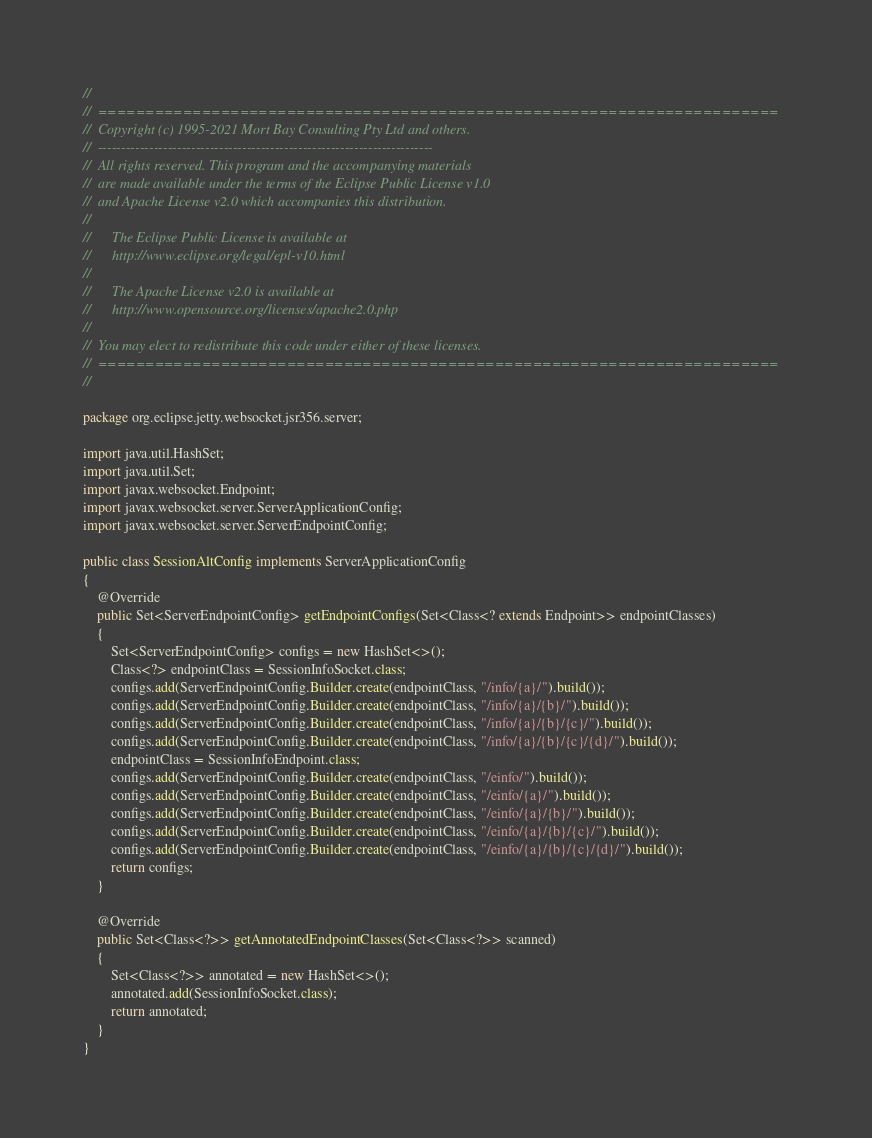<code> <loc_0><loc_0><loc_500><loc_500><_Java_>//
//  ========================================================================
//  Copyright (c) 1995-2021 Mort Bay Consulting Pty Ltd and others.
//  ------------------------------------------------------------------------
//  All rights reserved. This program and the accompanying materials
//  are made available under the terms of the Eclipse Public License v1.0
//  and Apache License v2.0 which accompanies this distribution.
//
//      The Eclipse Public License is available at
//      http://www.eclipse.org/legal/epl-v10.html
//
//      The Apache License v2.0 is available at
//      http://www.opensource.org/licenses/apache2.0.php
//
//  You may elect to redistribute this code under either of these licenses.
//  ========================================================================
//

package org.eclipse.jetty.websocket.jsr356.server;

import java.util.HashSet;
import java.util.Set;
import javax.websocket.Endpoint;
import javax.websocket.server.ServerApplicationConfig;
import javax.websocket.server.ServerEndpointConfig;

public class SessionAltConfig implements ServerApplicationConfig
{
    @Override
    public Set<ServerEndpointConfig> getEndpointConfigs(Set<Class<? extends Endpoint>> endpointClasses)
    {
        Set<ServerEndpointConfig> configs = new HashSet<>();
        Class<?> endpointClass = SessionInfoSocket.class;
        configs.add(ServerEndpointConfig.Builder.create(endpointClass, "/info/{a}/").build());
        configs.add(ServerEndpointConfig.Builder.create(endpointClass, "/info/{a}/{b}/").build());
        configs.add(ServerEndpointConfig.Builder.create(endpointClass, "/info/{a}/{b}/{c}/").build());
        configs.add(ServerEndpointConfig.Builder.create(endpointClass, "/info/{a}/{b}/{c}/{d}/").build());
        endpointClass = SessionInfoEndpoint.class;
        configs.add(ServerEndpointConfig.Builder.create(endpointClass, "/einfo/").build());
        configs.add(ServerEndpointConfig.Builder.create(endpointClass, "/einfo/{a}/").build());
        configs.add(ServerEndpointConfig.Builder.create(endpointClass, "/einfo/{a}/{b}/").build());
        configs.add(ServerEndpointConfig.Builder.create(endpointClass, "/einfo/{a}/{b}/{c}/").build());
        configs.add(ServerEndpointConfig.Builder.create(endpointClass, "/einfo/{a}/{b}/{c}/{d}/").build());
        return configs;
    }

    @Override
    public Set<Class<?>> getAnnotatedEndpointClasses(Set<Class<?>> scanned)
    {
        Set<Class<?>> annotated = new HashSet<>();
        annotated.add(SessionInfoSocket.class);
        return annotated;
    }
}
</code> 